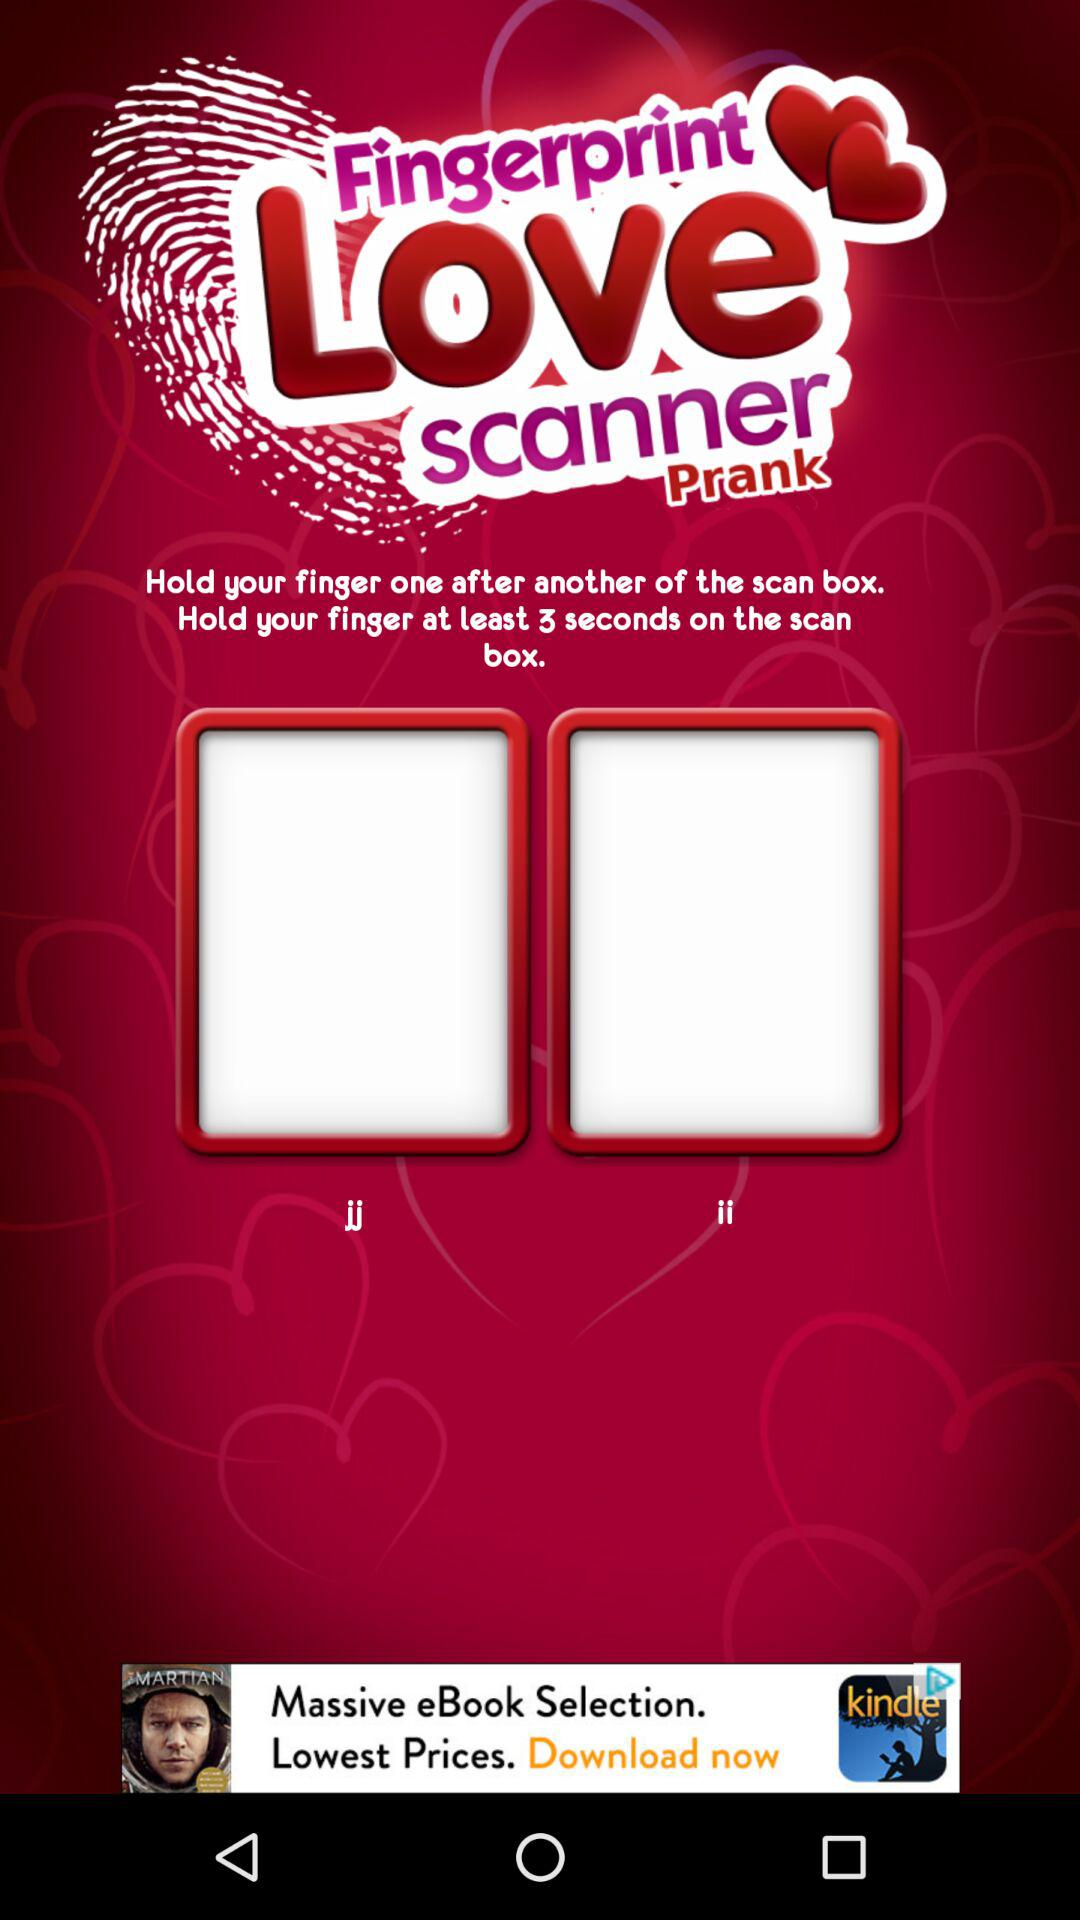What is the name of the application? The name of the application is "Fingerprint Love scanner Prank". 